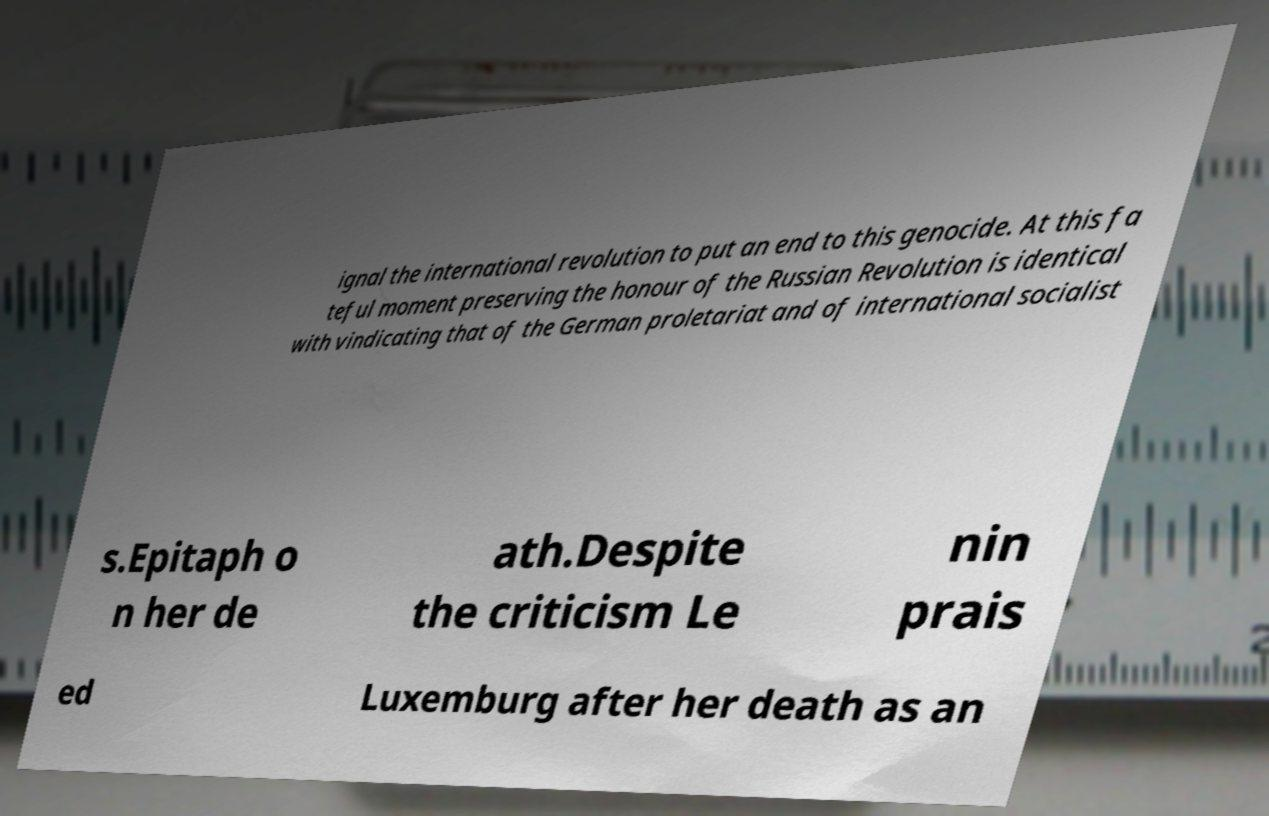Could you assist in decoding the text presented in this image and type it out clearly? ignal the international revolution to put an end to this genocide. At this fa teful moment preserving the honour of the Russian Revolution is identical with vindicating that of the German proletariat and of international socialist s.Epitaph o n her de ath.Despite the criticism Le nin prais ed Luxemburg after her death as an 